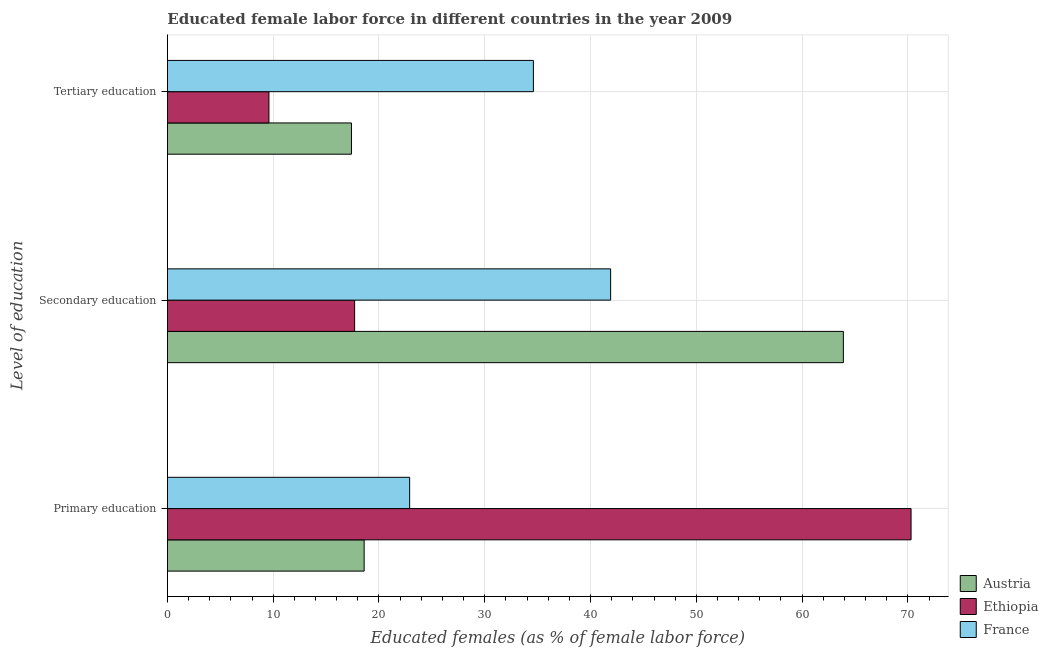How many groups of bars are there?
Your response must be concise. 3. Are the number of bars per tick equal to the number of legend labels?
Keep it short and to the point. Yes. How many bars are there on the 1st tick from the bottom?
Offer a very short reply. 3. What is the percentage of female labor force who received tertiary education in France?
Provide a short and direct response. 34.6. Across all countries, what is the maximum percentage of female labor force who received primary education?
Give a very brief answer. 70.3. Across all countries, what is the minimum percentage of female labor force who received tertiary education?
Give a very brief answer. 9.6. In which country was the percentage of female labor force who received primary education maximum?
Give a very brief answer. Ethiopia. In which country was the percentage of female labor force who received secondary education minimum?
Your answer should be very brief. Ethiopia. What is the total percentage of female labor force who received tertiary education in the graph?
Provide a succinct answer. 61.6. What is the difference between the percentage of female labor force who received primary education in Austria and that in Ethiopia?
Offer a terse response. -51.7. What is the difference between the percentage of female labor force who received secondary education in France and the percentage of female labor force who received primary education in Ethiopia?
Keep it short and to the point. -28.4. What is the average percentage of female labor force who received primary education per country?
Provide a short and direct response. 37.27. What is the difference between the percentage of female labor force who received secondary education and percentage of female labor force who received tertiary education in France?
Make the answer very short. 7.3. In how many countries, is the percentage of female labor force who received primary education greater than 44 %?
Make the answer very short. 1. What is the ratio of the percentage of female labor force who received tertiary education in Austria to that in France?
Offer a terse response. 0.5. Is the difference between the percentage of female labor force who received tertiary education in Austria and France greater than the difference between the percentage of female labor force who received secondary education in Austria and France?
Ensure brevity in your answer.  No. What is the difference between the highest and the lowest percentage of female labor force who received tertiary education?
Provide a short and direct response. 25. In how many countries, is the percentage of female labor force who received primary education greater than the average percentage of female labor force who received primary education taken over all countries?
Your answer should be compact. 1. What does the 2nd bar from the bottom in Tertiary education represents?
Ensure brevity in your answer.  Ethiopia. Is it the case that in every country, the sum of the percentage of female labor force who received primary education and percentage of female labor force who received secondary education is greater than the percentage of female labor force who received tertiary education?
Offer a terse response. Yes. Are the values on the major ticks of X-axis written in scientific E-notation?
Give a very brief answer. No. Does the graph contain grids?
Make the answer very short. Yes. Where does the legend appear in the graph?
Offer a terse response. Bottom right. What is the title of the graph?
Make the answer very short. Educated female labor force in different countries in the year 2009. What is the label or title of the X-axis?
Your response must be concise. Educated females (as % of female labor force). What is the label or title of the Y-axis?
Provide a succinct answer. Level of education. What is the Educated females (as % of female labor force) in Austria in Primary education?
Keep it short and to the point. 18.6. What is the Educated females (as % of female labor force) in Ethiopia in Primary education?
Offer a very short reply. 70.3. What is the Educated females (as % of female labor force) in France in Primary education?
Your response must be concise. 22.9. What is the Educated females (as % of female labor force) in Austria in Secondary education?
Ensure brevity in your answer.  63.9. What is the Educated females (as % of female labor force) in Ethiopia in Secondary education?
Your answer should be very brief. 17.7. What is the Educated females (as % of female labor force) of France in Secondary education?
Give a very brief answer. 41.9. What is the Educated females (as % of female labor force) in Austria in Tertiary education?
Ensure brevity in your answer.  17.4. What is the Educated females (as % of female labor force) of Ethiopia in Tertiary education?
Provide a succinct answer. 9.6. What is the Educated females (as % of female labor force) of France in Tertiary education?
Ensure brevity in your answer.  34.6. Across all Level of education, what is the maximum Educated females (as % of female labor force) in Austria?
Offer a terse response. 63.9. Across all Level of education, what is the maximum Educated females (as % of female labor force) of Ethiopia?
Offer a very short reply. 70.3. Across all Level of education, what is the maximum Educated females (as % of female labor force) in France?
Provide a succinct answer. 41.9. Across all Level of education, what is the minimum Educated females (as % of female labor force) of Austria?
Provide a short and direct response. 17.4. Across all Level of education, what is the minimum Educated females (as % of female labor force) of Ethiopia?
Ensure brevity in your answer.  9.6. Across all Level of education, what is the minimum Educated females (as % of female labor force) of France?
Keep it short and to the point. 22.9. What is the total Educated females (as % of female labor force) in Austria in the graph?
Provide a short and direct response. 99.9. What is the total Educated females (as % of female labor force) in Ethiopia in the graph?
Your response must be concise. 97.6. What is the total Educated females (as % of female labor force) in France in the graph?
Provide a short and direct response. 99.4. What is the difference between the Educated females (as % of female labor force) of Austria in Primary education and that in Secondary education?
Offer a terse response. -45.3. What is the difference between the Educated females (as % of female labor force) of Ethiopia in Primary education and that in Secondary education?
Your answer should be compact. 52.6. What is the difference between the Educated females (as % of female labor force) in France in Primary education and that in Secondary education?
Offer a very short reply. -19. What is the difference between the Educated females (as % of female labor force) in Ethiopia in Primary education and that in Tertiary education?
Offer a very short reply. 60.7. What is the difference between the Educated females (as % of female labor force) of France in Primary education and that in Tertiary education?
Your answer should be very brief. -11.7. What is the difference between the Educated females (as % of female labor force) in Austria in Secondary education and that in Tertiary education?
Your answer should be very brief. 46.5. What is the difference between the Educated females (as % of female labor force) of France in Secondary education and that in Tertiary education?
Keep it short and to the point. 7.3. What is the difference between the Educated females (as % of female labor force) of Austria in Primary education and the Educated females (as % of female labor force) of Ethiopia in Secondary education?
Keep it short and to the point. 0.9. What is the difference between the Educated females (as % of female labor force) of Austria in Primary education and the Educated females (as % of female labor force) of France in Secondary education?
Your response must be concise. -23.3. What is the difference between the Educated females (as % of female labor force) in Ethiopia in Primary education and the Educated females (as % of female labor force) in France in Secondary education?
Your answer should be compact. 28.4. What is the difference between the Educated females (as % of female labor force) in Austria in Primary education and the Educated females (as % of female labor force) in Ethiopia in Tertiary education?
Offer a very short reply. 9. What is the difference between the Educated females (as % of female labor force) in Ethiopia in Primary education and the Educated females (as % of female labor force) in France in Tertiary education?
Provide a succinct answer. 35.7. What is the difference between the Educated females (as % of female labor force) in Austria in Secondary education and the Educated females (as % of female labor force) in Ethiopia in Tertiary education?
Ensure brevity in your answer.  54.3. What is the difference between the Educated females (as % of female labor force) of Austria in Secondary education and the Educated females (as % of female labor force) of France in Tertiary education?
Your answer should be compact. 29.3. What is the difference between the Educated females (as % of female labor force) of Ethiopia in Secondary education and the Educated females (as % of female labor force) of France in Tertiary education?
Provide a succinct answer. -16.9. What is the average Educated females (as % of female labor force) in Austria per Level of education?
Offer a very short reply. 33.3. What is the average Educated females (as % of female labor force) in Ethiopia per Level of education?
Provide a short and direct response. 32.53. What is the average Educated females (as % of female labor force) in France per Level of education?
Give a very brief answer. 33.13. What is the difference between the Educated females (as % of female labor force) of Austria and Educated females (as % of female labor force) of Ethiopia in Primary education?
Give a very brief answer. -51.7. What is the difference between the Educated females (as % of female labor force) of Ethiopia and Educated females (as % of female labor force) of France in Primary education?
Your answer should be compact. 47.4. What is the difference between the Educated females (as % of female labor force) in Austria and Educated females (as % of female labor force) in Ethiopia in Secondary education?
Your answer should be very brief. 46.2. What is the difference between the Educated females (as % of female labor force) of Ethiopia and Educated females (as % of female labor force) of France in Secondary education?
Ensure brevity in your answer.  -24.2. What is the difference between the Educated females (as % of female labor force) of Austria and Educated females (as % of female labor force) of France in Tertiary education?
Offer a very short reply. -17.2. What is the ratio of the Educated females (as % of female labor force) in Austria in Primary education to that in Secondary education?
Provide a succinct answer. 0.29. What is the ratio of the Educated females (as % of female labor force) in Ethiopia in Primary education to that in Secondary education?
Your response must be concise. 3.97. What is the ratio of the Educated females (as % of female labor force) of France in Primary education to that in Secondary education?
Provide a short and direct response. 0.55. What is the ratio of the Educated females (as % of female labor force) of Austria in Primary education to that in Tertiary education?
Provide a short and direct response. 1.07. What is the ratio of the Educated females (as % of female labor force) in Ethiopia in Primary education to that in Tertiary education?
Offer a very short reply. 7.32. What is the ratio of the Educated females (as % of female labor force) in France in Primary education to that in Tertiary education?
Provide a short and direct response. 0.66. What is the ratio of the Educated females (as % of female labor force) in Austria in Secondary education to that in Tertiary education?
Provide a succinct answer. 3.67. What is the ratio of the Educated females (as % of female labor force) in Ethiopia in Secondary education to that in Tertiary education?
Your answer should be very brief. 1.84. What is the ratio of the Educated females (as % of female labor force) in France in Secondary education to that in Tertiary education?
Your response must be concise. 1.21. What is the difference between the highest and the second highest Educated females (as % of female labor force) of Austria?
Your response must be concise. 45.3. What is the difference between the highest and the second highest Educated females (as % of female labor force) of Ethiopia?
Your response must be concise. 52.6. What is the difference between the highest and the lowest Educated females (as % of female labor force) in Austria?
Your answer should be compact. 46.5. What is the difference between the highest and the lowest Educated females (as % of female labor force) in Ethiopia?
Your answer should be compact. 60.7. 